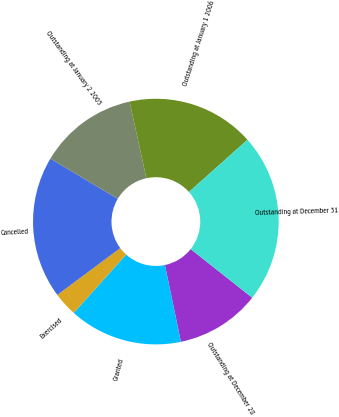<chart> <loc_0><loc_0><loc_500><loc_500><pie_chart><fcel>Outstanding at December 28<fcel>Granted<fcel>Exercised<fcel>Cancelled<fcel>Outstanding at January 2 2005<fcel>Outstanding at January 1 2006<fcel>Outstanding at December 31<nl><fcel>11.09%<fcel>14.92%<fcel>3.16%<fcel>18.75%<fcel>13.0%<fcel>16.83%<fcel>22.24%<nl></chart> 